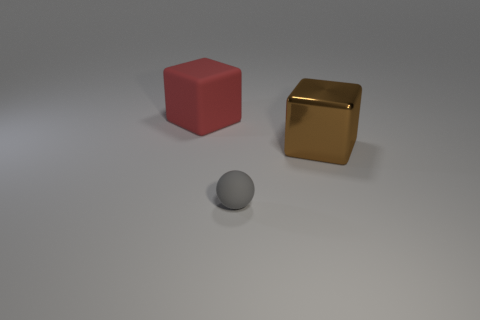Could you describe the lighting and mood of the scene depicted in the image? The image features a soft, diffused light casting gentle shadows, suggesting an indoor setting with ambient lighting. This creates a calm and nondescript mood, potentially in a setting used for 3D modeling or product visualization. 